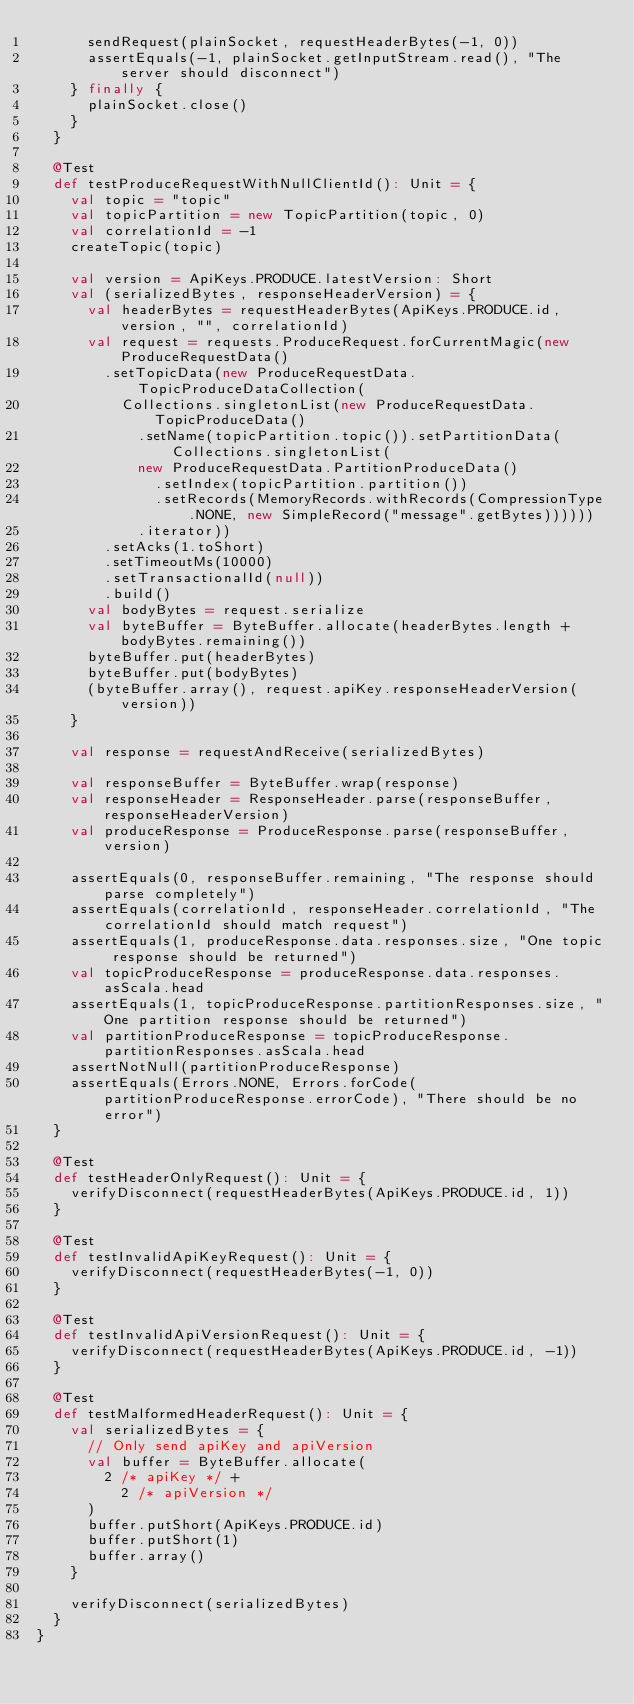<code> <loc_0><loc_0><loc_500><loc_500><_Scala_>      sendRequest(plainSocket, requestHeaderBytes(-1, 0))
      assertEquals(-1, plainSocket.getInputStream.read(), "The server should disconnect")
    } finally {
      plainSocket.close()
    }
  }

  @Test
  def testProduceRequestWithNullClientId(): Unit = {
    val topic = "topic"
    val topicPartition = new TopicPartition(topic, 0)
    val correlationId = -1
    createTopic(topic)

    val version = ApiKeys.PRODUCE.latestVersion: Short
    val (serializedBytes, responseHeaderVersion) = {
      val headerBytes = requestHeaderBytes(ApiKeys.PRODUCE.id, version, "", correlationId)
      val request = requests.ProduceRequest.forCurrentMagic(new ProduceRequestData()
        .setTopicData(new ProduceRequestData.TopicProduceDataCollection(
          Collections.singletonList(new ProduceRequestData.TopicProduceData()
            .setName(topicPartition.topic()).setPartitionData(Collections.singletonList(
            new ProduceRequestData.PartitionProduceData()
              .setIndex(topicPartition.partition())
              .setRecords(MemoryRecords.withRecords(CompressionType.NONE, new SimpleRecord("message".getBytes))))))
            .iterator))
        .setAcks(1.toShort)
        .setTimeoutMs(10000)
        .setTransactionalId(null))
        .build()
      val bodyBytes = request.serialize
      val byteBuffer = ByteBuffer.allocate(headerBytes.length + bodyBytes.remaining())
      byteBuffer.put(headerBytes)
      byteBuffer.put(bodyBytes)
      (byteBuffer.array(), request.apiKey.responseHeaderVersion(version))
    }

    val response = requestAndReceive(serializedBytes)

    val responseBuffer = ByteBuffer.wrap(response)
    val responseHeader = ResponseHeader.parse(responseBuffer, responseHeaderVersion)
    val produceResponse = ProduceResponse.parse(responseBuffer, version)

    assertEquals(0, responseBuffer.remaining, "The response should parse completely")
    assertEquals(correlationId, responseHeader.correlationId, "The correlationId should match request")
    assertEquals(1, produceResponse.data.responses.size, "One topic response should be returned")
    val topicProduceResponse = produceResponse.data.responses.asScala.head
    assertEquals(1, topicProduceResponse.partitionResponses.size, "One partition response should be returned")    
    val partitionProduceResponse = topicProduceResponse.partitionResponses.asScala.head
    assertNotNull(partitionProduceResponse)
    assertEquals(Errors.NONE, Errors.forCode(partitionProduceResponse.errorCode), "There should be no error")
  }

  @Test
  def testHeaderOnlyRequest(): Unit = {
    verifyDisconnect(requestHeaderBytes(ApiKeys.PRODUCE.id, 1))
  }

  @Test
  def testInvalidApiKeyRequest(): Unit = {
    verifyDisconnect(requestHeaderBytes(-1, 0))
  }

  @Test
  def testInvalidApiVersionRequest(): Unit = {
    verifyDisconnect(requestHeaderBytes(ApiKeys.PRODUCE.id, -1))
  }

  @Test
  def testMalformedHeaderRequest(): Unit = {
    val serializedBytes = {
      // Only send apiKey and apiVersion
      val buffer = ByteBuffer.allocate(
        2 /* apiKey */ +
          2 /* apiVersion */
      )
      buffer.putShort(ApiKeys.PRODUCE.id)
      buffer.putShort(1)
      buffer.array()
    }

    verifyDisconnect(serializedBytes)
  }
}
</code> 